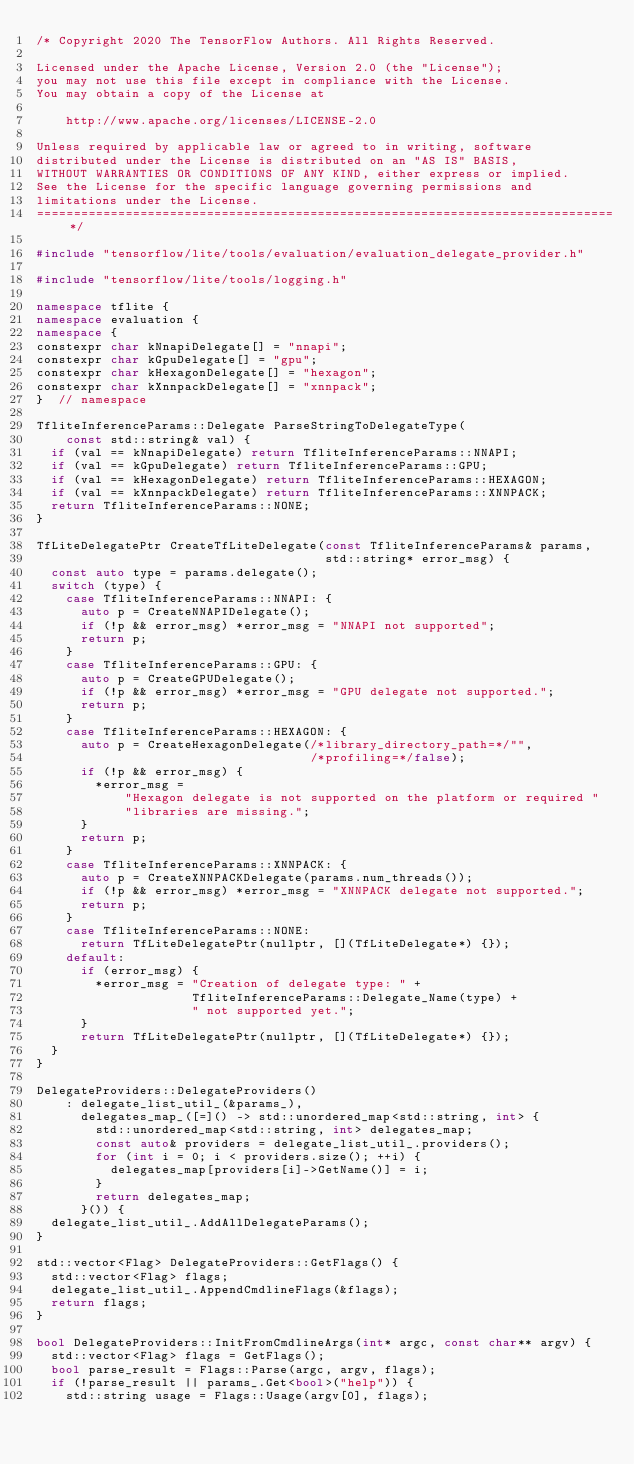Convert code to text. <code><loc_0><loc_0><loc_500><loc_500><_C++_>/* Copyright 2020 The TensorFlow Authors. All Rights Reserved.

Licensed under the Apache License, Version 2.0 (the "License");
you may not use this file except in compliance with the License.
You may obtain a copy of the License at

    http://www.apache.org/licenses/LICENSE-2.0

Unless required by applicable law or agreed to in writing, software
distributed under the License is distributed on an "AS IS" BASIS,
WITHOUT WARRANTIES OR CONDITIONS OF ANY KIND, either express or implied.
See the License for the specific language governing permissions and
limitations under the License.
==============================================================================*/

#include "tensorflow/lite/tools/evaluation/evaluation_delegate_provider.h"

#include "tensorflow/lite/tools/logging.h"

namespace tflite {
namespace evaluation {
namespace {
constexpr char kNnapiDelegate[] = "nnapi";
constexpr char kGpuDelegate[] = "gpu";
constexpr char kHexagonDelegate[] = "hexagon";
constexpr char kXnnpackDelegate[] = "xnnpack";
}  // namespace

TfliteInferenceParams::Delegate ParseStringToDelegateType(
    const std::string& val) {
  if (val == kNnapiDelegate) return TfliteInferenceParams::NNAPI;
  if (val == kGpuDelegate) return TfliteInferenceParams::GPU;
  if (val == kHexagonDelegate) return TfliteInferenceParams::HEXAGON;
  if (val == kXnnpackDelegate) return TfliteInferenceParams::XNNPACK;
  return TfliteInferenceParams::NONE;
}

TfLiteDelegatePtr CreateTfLiteDelegate(const TfliteInferenceParams& params,
                                       std::string* error_msg) {
  const auto type = params.delegate();
  switch (type) {
    case TfliteInferenceParams::NNAPI: {
      auto p = CreateNNAPIDelegate();
      if (!p && error_msg) *error_msg = "NNAPI not supported";
      return p;
    }
    case TfliteInferenceParams::GPU: {
      auto p = CreateGPUDelegate();
      if (!p && error_msg) *error_msg = "GPU delegate not supported.";
      return p;
    }
    case TfliteInferenceParams::HEXAGON: {
      auto p = CreateHexagonDelegate(/*library_directory_path=*/"",
                                     /*profiling=*/false);
      if (!p && error_msg) {
        *error_msg =
            "Hexagon delegate is not supported on the platform or required "
            "libraries are missing.";
      }
      return p;
    }
    case TfliteInferenceParams::XNNPACK: {
      auto p = CreateXNNPACKDelegate(params.num_threads());
      if (!p && error_msg) *error_msg = "XNNPACK delegate not supported.";
      return p;
    }
    case TfliteInferenceParams::NONE:
      return TfLiteDelegatePtr(nullptr, [](TfLiteDelegate*) {});
    default:
      if (error_msg) {
        *error_msg = "Creation of delegate type: " +
                     TfliteInferenceParams::Delegate_Name(type) +
                     " not supported yet.";
      }
      return TfLiteDelegatePtr(nullptr, [](TfLiteDelegate*) {});
  }
}

DelegateProviders::DelegateProviders()
    : delegate_list_util_(&params_),
      delegates_map_([=]() -> std::unordered_map<std::string, int> {
        std::unordered_map<std::string, int> delegates_map;
        const auto& providers = delegate_list_util_.providers();
        for (int i = 0; i < providers.size(); ++i) {
          delegates_map[providers[i]->GetName()] = i;
        }
        return delegates_map;
      }()) {
  delegate_list_util_.AddAllDelegateParams();
}

std::vector<Flag> DelegateProviders::GetFlags() {
  std::vector<Flag> flags;
  delegate_list_util_.AppendCmdlineFlags(&flags);
  return flags;
}

bool DelegateProviders::InitFromCmdlineArgs(int* argc, const char** argv) {
  std::vector<Flag> flags = GetFlags();
  bool parse_result = Flags::Parse(argc, argv, flags);
  if (!parse_result || params_.Get<bool>("help")) {
    std::string usage = Flags::Usage(argv[0], flags);</code> 